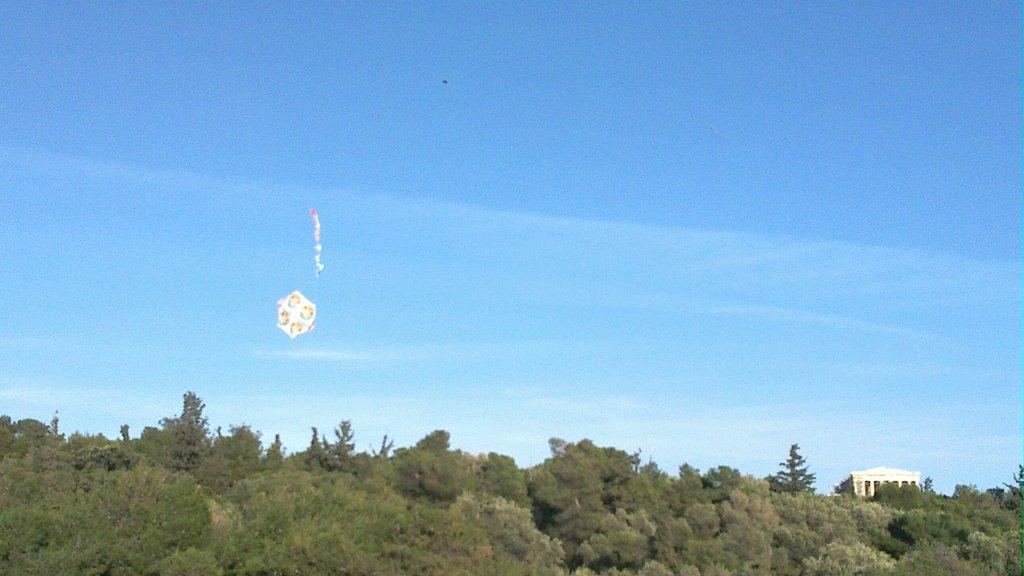What type of vegetation is present at the bottom of the image? There are many trees at the bottom of the image. What type of structure is also present at the bottom of the image? There is a house at the bottom of the image. What is the unspecified object in the air? Unfortunately, the facts provided do not give enough information to determine what the unspecified object in the air is. What can be seen in the background of the image? The sky is visible in the background of the image. What is the price of the dirt visible in the image? There is no dirt visible in the image, and therefore no price can be determined. What news is being reported by the trees at the bottom of the image? There is no news being reported by the trees in the image; they are simply trees. 